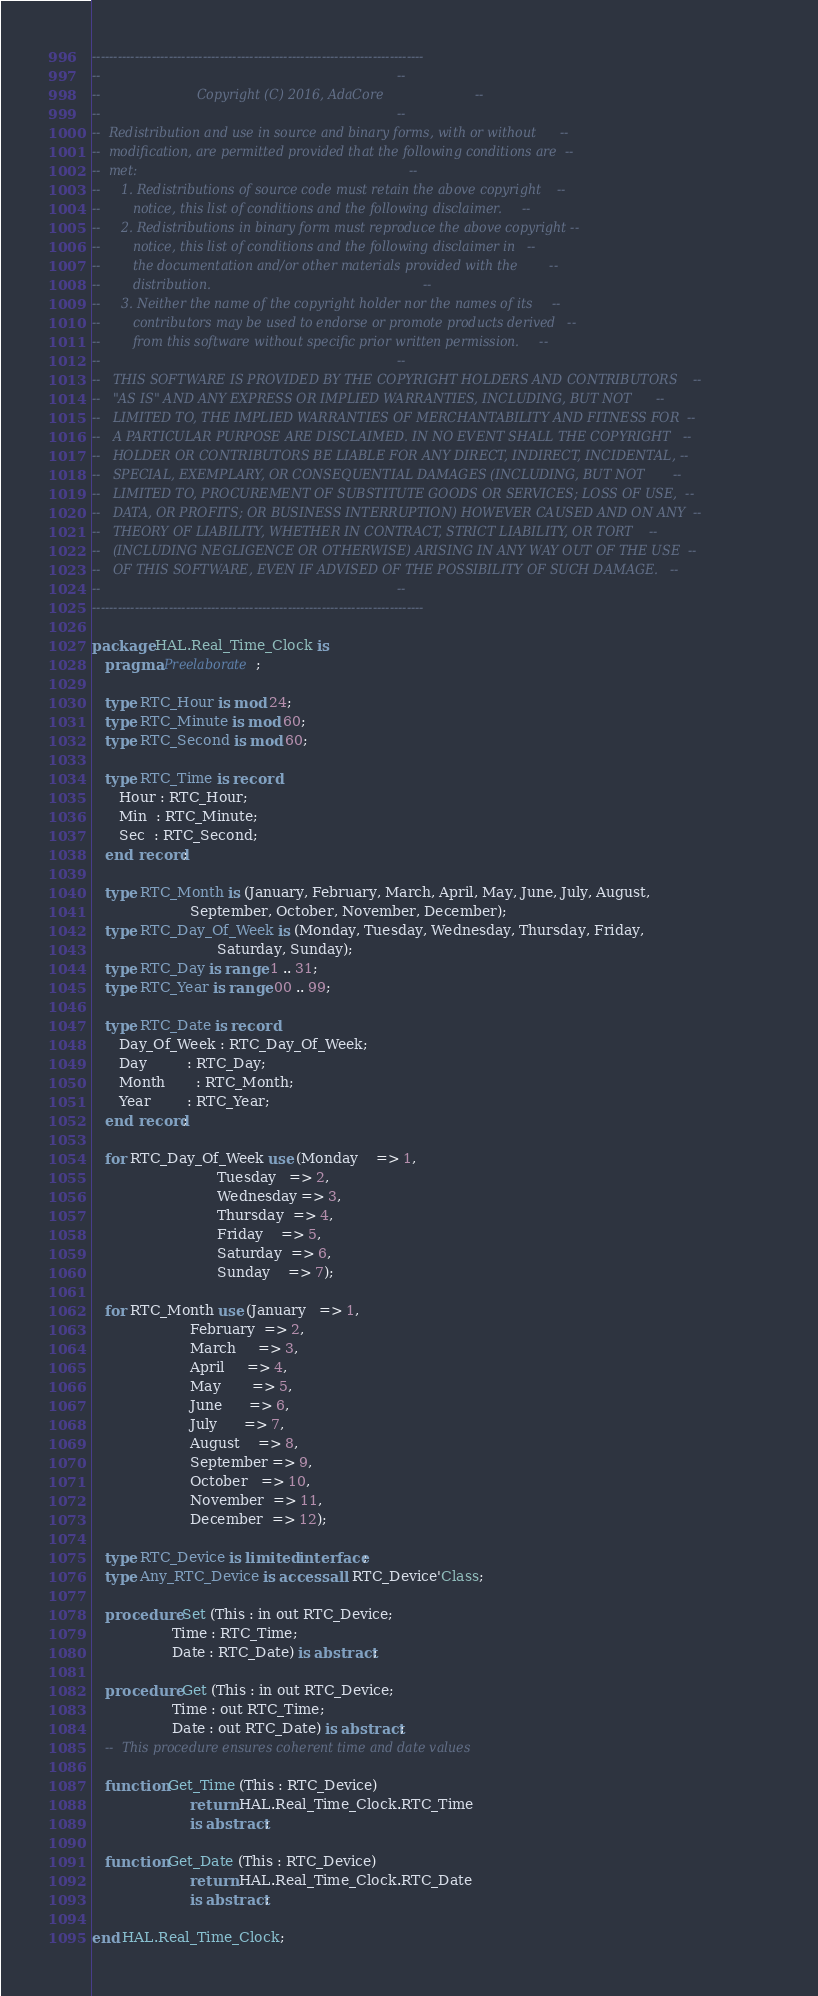<code> <loc_0><loc_0><loc_500><loc_500><_Ada_>------------------------------------------------------------------------------
--                                                                          --
--                        Copyright (C) 2016, AdaCore                       --
--                                                                          --
--  Redistribution and use in source and binary forms, with or without      --
--  modification, are permitted provided that the following conditions are  --
--  met:                                                                    --
--     1. Redistributions of source code must retain the above copyright    --
--        notice, this list of conditions and the following disclaimer.     --
--     2. Redistributions in binary form must reproduce the above copyright --
--        notice, this list of conditions and the following disclaimer in   --
--        the documentation and/or other materials provided with the        --
--        distribution.                                                     --
--     3. Neither the name of the copyright holder nor the names of its     --
--        contributors may be used to endorse or promote products derived   --
--        from this software without specific prior written permission.     --
--                                                                          --
--   THIS SOFTWARE IS PROVIDED BY THE COPYRIGHT HOLDERS AND CONTRIBUTORS    --
--   "AS IS" AND ANY EXPRESS OR IMPLIED WARRANTIES, INCLUDING, BUT NOT      --
--   LIMITED TO, THE IMPLIED WARRANTIES OF MERCHANTABILITY AND FITNESS FOR  --
--   A PARTICULAR PURPOSE ARE DISCLAIMED. IN NO EVENT SHALL THE COPYRIGHT   --
--   HOLDER OR CONTRIBUTORS BE LIABLE FOR ANY DIRECT, INDIRECT, INCIDENTAL, --
--   SPECIAL, EXEMPLARY, OR CONSEQUENTIAL DAMAGES (INCLUDING, BUT NOT       --
--   LIMITED TO, PROCUREMENT OF SUBSTITUTE GOODS OR SERVICES; LOSS OF USE,  --
--   DATA, OR PROFITS; OR BUSINESS INTERRUPTION) HOWEVER CAUSED AND ON ANY  --
--   THEORY OF LIABILITY, WHETHER IN CONTRACT, STRICT LIABILITY, OR TORT    --
--   (INCLUDING NEGLIGENCE OR OTHERWISE) ARISING IN ANY WAY OUT OF THE USE  --
--   OF THIS SOFTWARE, EVEN IF ADVISED OF THE POSSIBILITY OF SUCH DAMAGE.   --
--                                                                          --
------------------------------------------------------------------------------

package HAL.Real_Time_Clock is
   pragma Preelaborate;

   type RTC_Hour is mod 24;
   type RTC_Minute is mod 60;
   type RTC_Second is mod 60;

   type RTC_Time is record
      Hour : RTC_Hour;
      Min  : RTC_Minute;
      Sec  : RTC_Second;
   end record;

   type RTC_Month is (January, February, March, April, May, June, July, August,
                      September, October, November, December);
   type RTC_Day_Of_Week is (Monday, Tuesday, Wednesday, Thursday, Friday,
                            Saturday, Sunday);
   type RTC_Day is range 1 .. 31;
   type RTC_Year is range 00 .. 99;

   type RTC_Date is record
      Day_Of_Week : RTC_Day_Of_Week;
      Day         : RTC_Day;
      Month       : RTC_Month;
      Year        : RTC_Year;
   end record;

   for RTC_Day_Of_Week use (Monday    => 1,
                            Tuesday   => 2,
                            Wednesday => 3,
                            Thursday  => 4,
                            Friday    => 5,
                            Saturday  => 6,
                            Sunday    => 7);

   for RTC_Month use (January   => 1,
                      February  => 2,
                      March     => 3,
                      April     => 4,
                      May       => 5,
                      June      => 6,
                      July      => 7,
                      August    => 8,
                      September => 9,
                      October   => 10,
                      November  => 11,
                      December  => 12);

   type RTC_Device is limited interface;
   type Any_RTC_Device is access all RTC_Device'Class;

   procedure Set (This : in out RTC_Device;
                  Time : RTC_Time;
                  Date : RTC_Date) is abstract;

   procedure Get (This : in out RTC_Device;
                  Time : out RTC_Time;
                  Date : out RTC_Date) is abstract;
   --  This procedure ensures coherent time and date values

   function Get_Time (This : RTC_Device)
                      return HAL.Real_Time_Clock.RTC_Time
                      is abstract;

   function Get_Date (This : RTC_Device)
                      return HAL.Real_Time_Clock.RTC_Date
                      is abstract;

end HAL.Real_Time_Clock;
</code> 